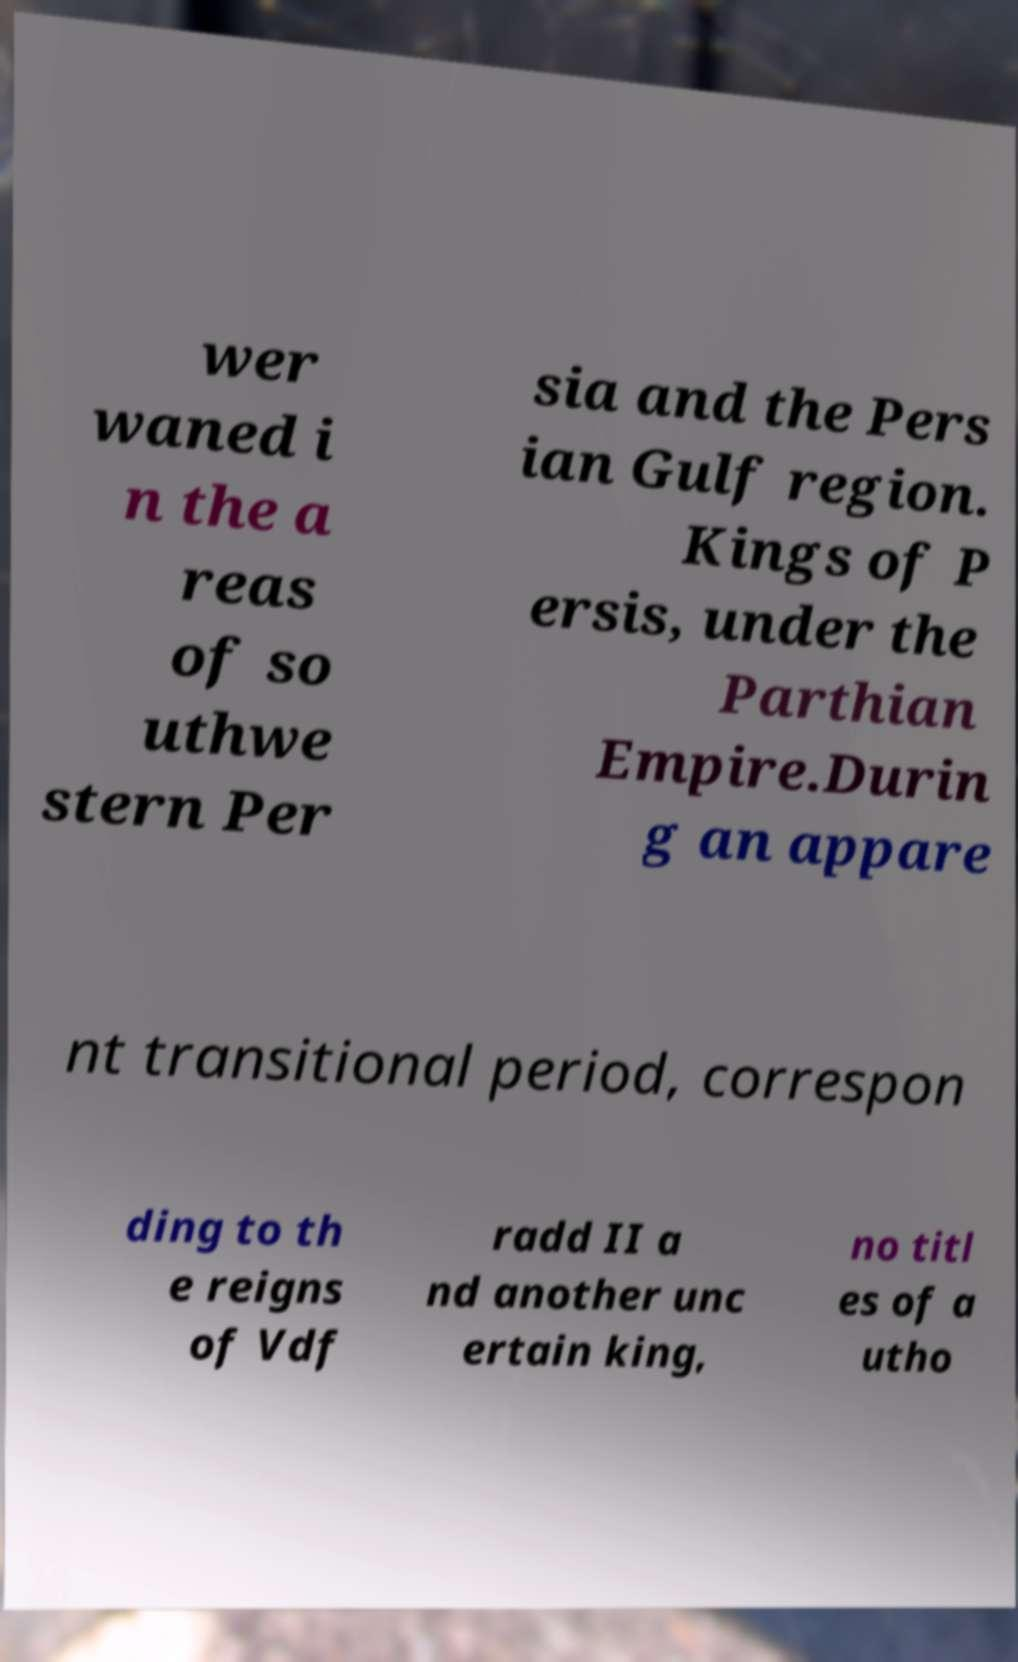What messages or text are displayed in this image? I need them in a readable, typed format. wer waned i n the a reas of so uthwe stern Per sia and the Pers ian Gulf region. Kings of P ersis, under the Parthian Empire.Durin g an appare nt transitional period, correspon ding to th e reigns of Vdf radd II a nd another unc ertain king, no titl es of a utho 